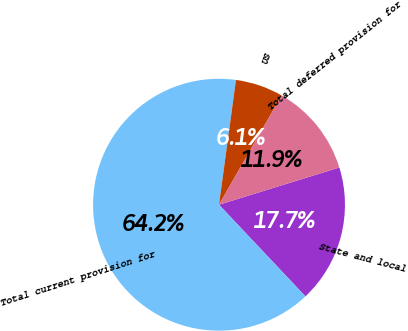<chart> <loc_0><loc_0><loc_500><loc_500><pie_chart><fcel>State and local<fcel>Total current provision for<fcel>US<fcel>Total deferred provision for<nl><fcel>17.74%<fcel>64.18%<fcel>6.13%<fcel>11.94%<nl></chart> 